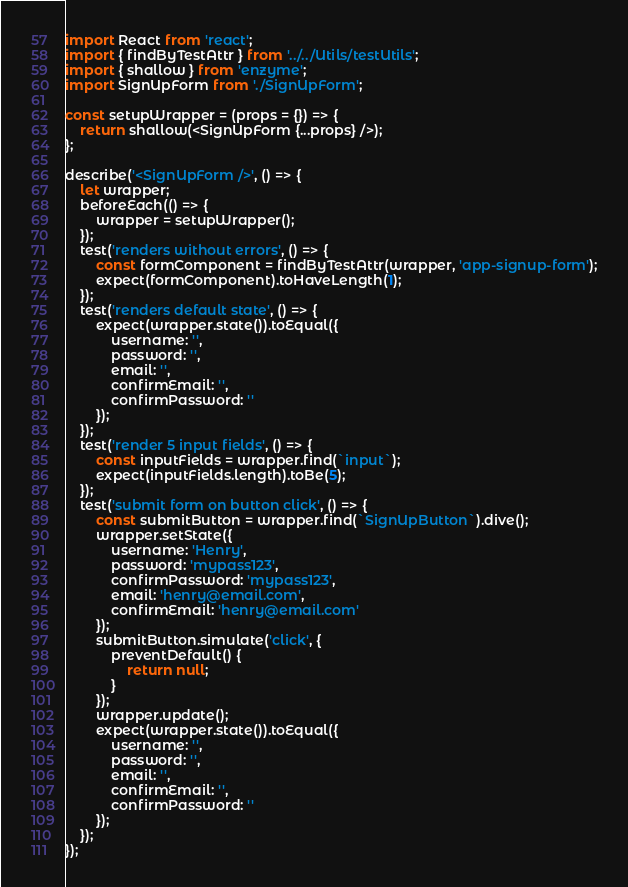Convert code to text. <code><loc_0><loc_0><loc_500><loc_500><_JavaScript_>import React from 'react';
import { findByTestAttr } from '../../Utils/testUtils';
import { shallow } from 'enzyme';
import SignUpForm from './SignUpForm';

const setupWrapper = (props = {}) => {
	return shallow(<SignUpForm {...props} />);
};

describe('<SignUpForm />', () => {
	let wrapper;
	beforeEach(() => {
		wrapper = setupWrapper();
	});
	test('renders without errors', () => {
		const formComponent = findByTestAttr(wrapper, 'app-signup-form');
		expect(formComponent).toHaveLength(1);
	});
	test('renders default state', () => {
		expect(wrapper.state()).toEqual({
			username: '',
			password: '',
			email: '',
			confirmEmail: '',
			confirmPassword: ''
		});
	});
	test('render 5 input fields', () => {
		const inputFields = wrapper.find(`input`);
		expect(inputFields.length).toBe(5);
	});
	test('submit form on button click', () => {
		const submitButton = wrapper.find(`SignUpButton`).dive();
		wrapper.setState({
			username: 'Henry',
			password: 'mypass123',
			confirmPassword: 'mypass123',
			email: 'henry@email.com',
			confirmEmail: 'henry@email.com'
		});
		submitButton.simulate('click', {
			preventDefault() {
				return null;
			}
		});
		wrapper.update();
		expect(wrapper.state()).toEqual({
			username: '',
			password: '',
			email: '',
			confirmEmail: '',
			confirmPassword: ''
		});
	});
});
</code> 